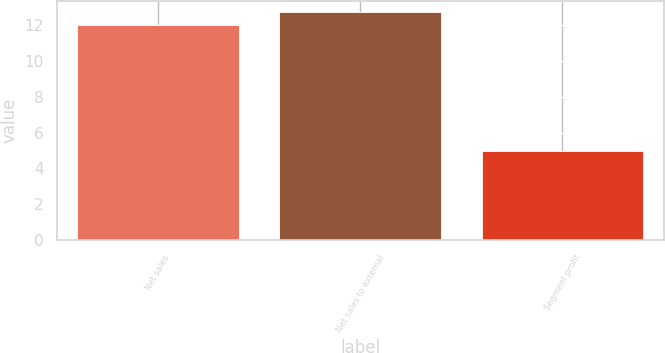<chart> <loc_0><loc_0><loc_500><loc_500><bar_chart><fcel>Net sales<fcel>Net sales to external<fcel>Segment profit<nl><fcel>12<fcel>12.7<fcel>5<nl></chart> 